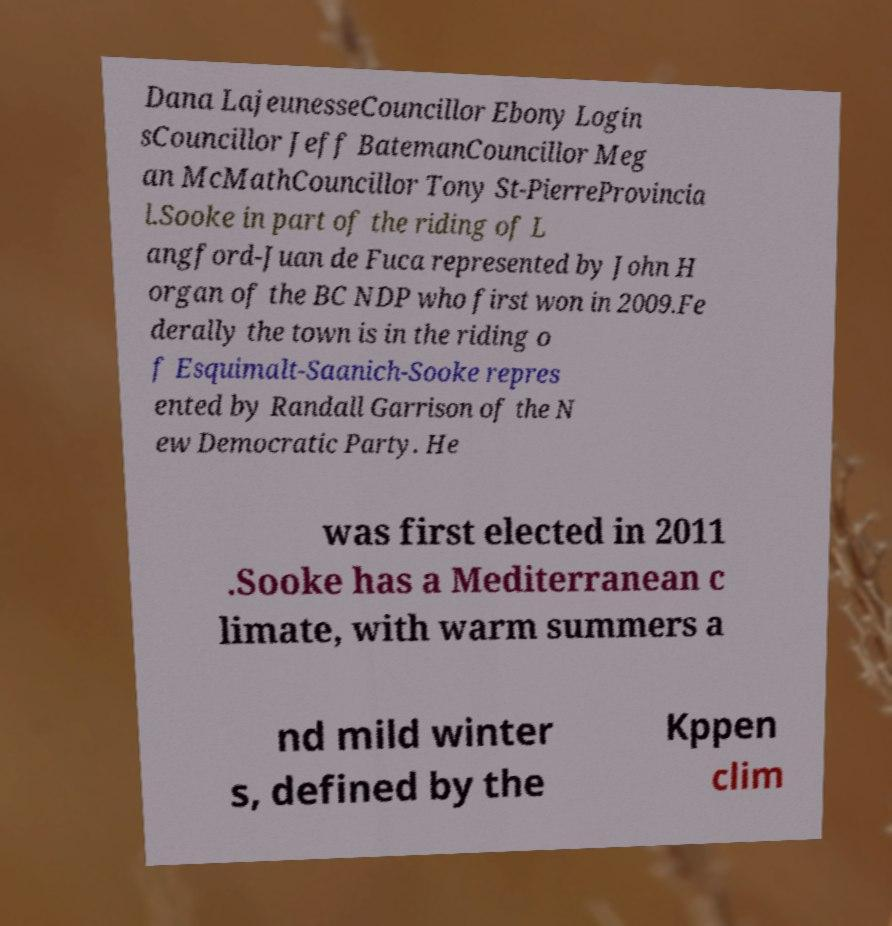Please identify and transcribe the text found in this image. Dana LajeunesseCouncillor Ebony Login sCouncillor Jeff BatemanCouncillor Meg an McMathCouncillor Tony St-PierreProvincia l.Sooke in part of the riding of L angford-Juan de Fuca represented by John H organ of the BC NDP who first won in 2009.Fe derally the town is in the riding o f Esquimalt-Saanich-Sooke repres ented by Randall Garrison of the N ew Democratic Party. He was first elected in 2011 .Sooke has a Mediterranean c limate, with warm summers a nd mild winter s, defined by the Kppen clim 